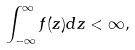<formula> <loc_0><loc_0><loc_500><loc_500>\int _ { - \infty } ^ { \infty } f ( z ) d z < \infty ,</formula> 